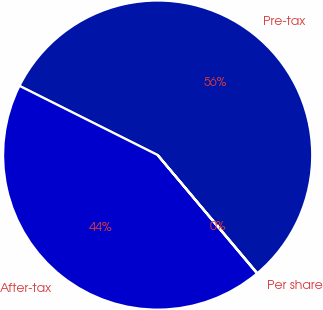Convert chart to OTSL. <chart><loc_0><loc_0><loc_500><loc_500><pie_chart><fcel>Pre-tax<fcel>After-tax<fcel>Per share<nl><fcel>56.46%<fcel>43.51%<fcel>0.03%<nl></chart> 